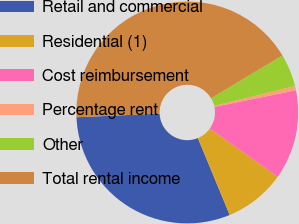<chart> <loc_0><loc_0><loc_500><loc_500><pie_chart><fcel>Retail and commercial<fcel>Residential (1)<fcel>Cost reimbursement<fcel>Percentage rent<fcel>Other<fcel>Total rental income<nl><fcel>30.56%<fcel>8.91%<fcel>13.06%<fcel>0.62%<fcel>4.77%<fcel>42.08%<nl></chart> 